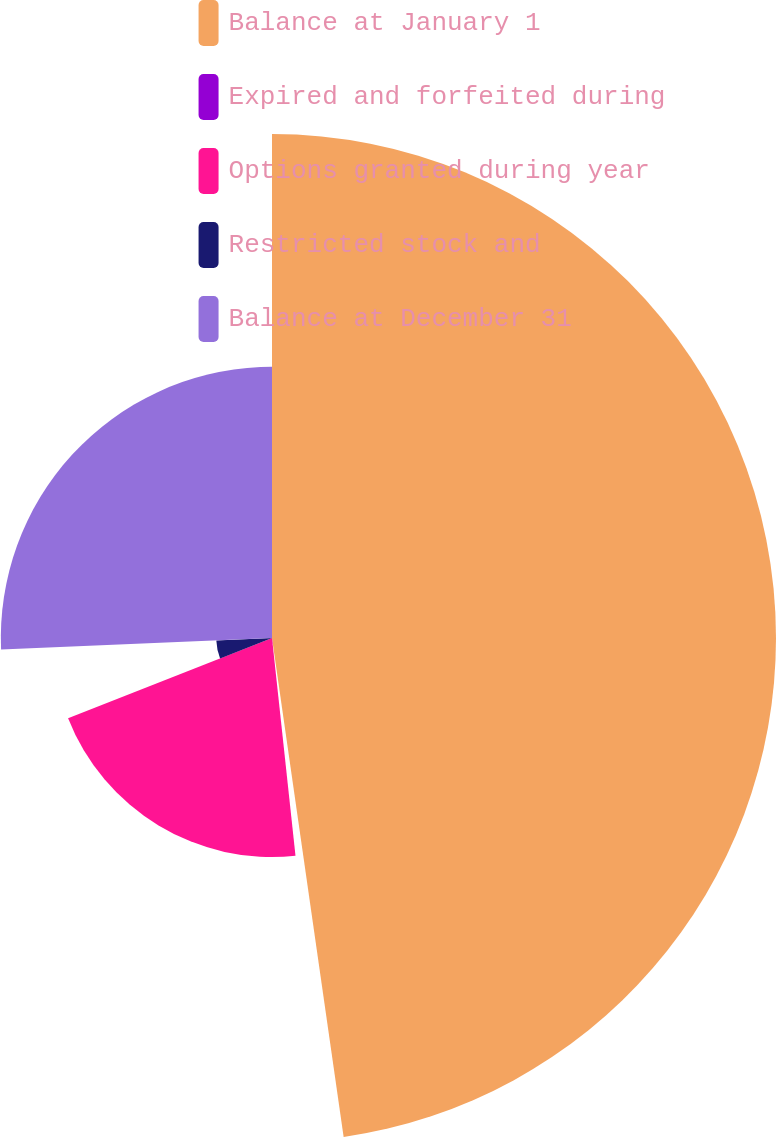<chart> <loc_0><loc_0><loc_500><loc_500><pie_chart><fcel>Balance at January 1<fcel>Expired and forfeited during<fcel>Options granted during year<fcel>Restricted stock and<fcel>Balance at December 31<nl><fcel>47.73%<fcel>0.56%<fcel>20.75%<fcel>5.28%<fcel>25.68%<nl></chart> 